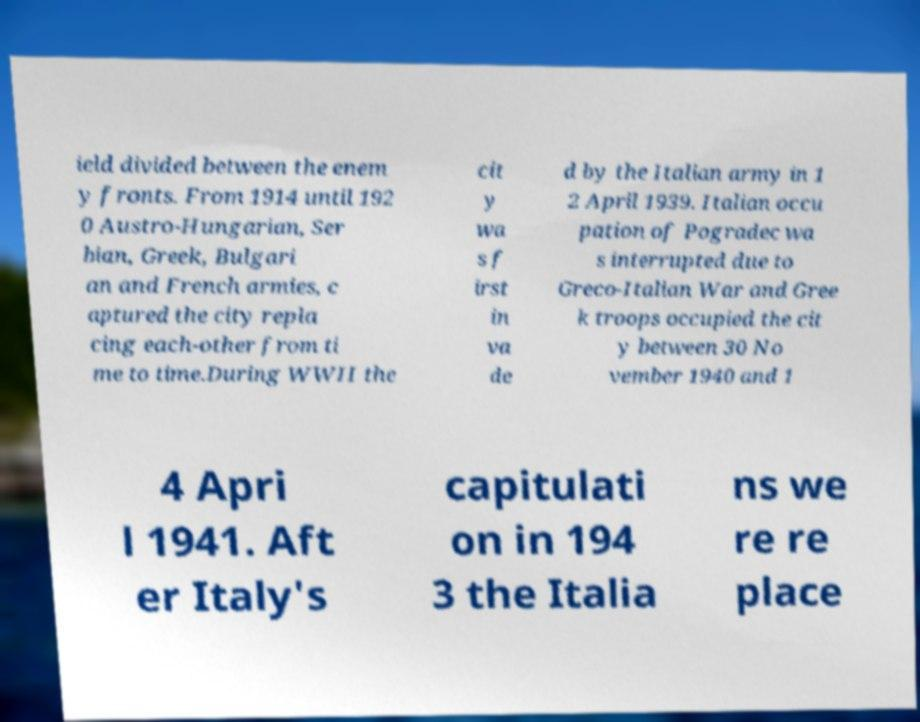Please read and relay the text visible in this image. What does it say? ield divided between the enem y fronts. From 1914 until 192 0 Austro-Hungarian, Ser bian, Greek, Bulgari an and French armies, c aptured the city repla cing each-other from ti me to time.During WWII the cit y wa s f irst in va de d by the Italian army in 1 2 April 1939. Italian occu pation of Pogradec wa s interrupted due to Greco-Italian War and Gree k troops occupied the cit y between 30 No vember 1940 and 1 4 Apri l 1941. Aft er Italy's capitulati on in 194 3 the Italia ns we re re place 